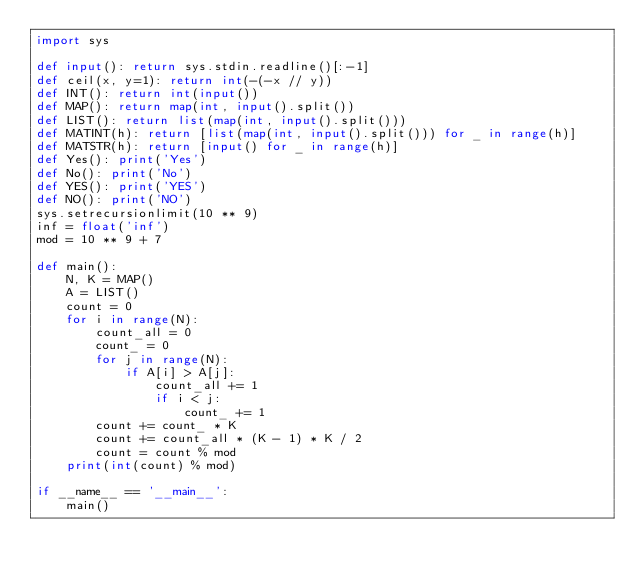<code> <loc_0><loc_0><loc_500><loc_500><_Python_>import sys

def input(): return sys.stdin.readline()[:-1]
def ceil(x, y=1): return int(-(-x // y))
def INT(): return int(input())
def MAP(): return map(int, input().split())
def LIST(): return list(map(int, input().split()))
def MATINT(h): return [list(map(int, input().split())) for _ in range(h)]
def MATSTR(h): return [input() for _ in range(h)]
def Yes(): print('Yes')
def No(): print('No')
def YES(): print('YES')
def NO(): print('NO')
sys.setrecursionlimit(10 ** 9)
inf = float('inf')
mod = 10 ** 9 + 7

def main():
    N, K = MAP()
    A = LIST()
    count = 0
    for i in range(N):
        count_all = 0
        count_ = 0
        for j in range(N):
            if A[i] > A[j]:
                count_all += 1
                if i < j:
                    count_ += 1
        count += count_ * K
        count += count_all * (K - 1) * K / 2
        count = count % mod
    print(int(count) % mod)

if __name__ == '__main__':
    main()
</code> 